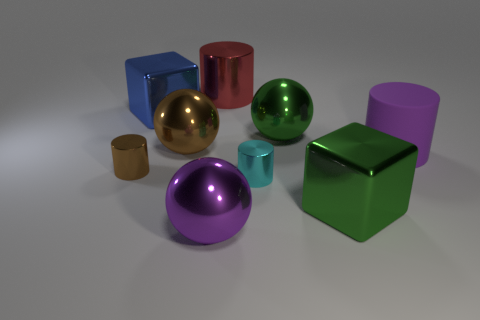Add 1 small cyan shiny cylinders. How many objects exist? 10 Subtract all big red cylinders. How many cylinders are left? 3 Subtract all yellow cylinders. Subtract all purple cubes. How many cylinders are left? 4 Subtract all cylinders. How many objects are left? 5 Add 5 big metallic cylinders. How many big metallic cylinders are left? 6 Add 8 red metallic cylinders. How many red metallic cylinders exist? 9 Subtract 1 green spheres. How many objects are left? 8 Subtract all tiny cyan shiny cylinders. Subtract all purple matte cylinders. How many objects are left? 7 